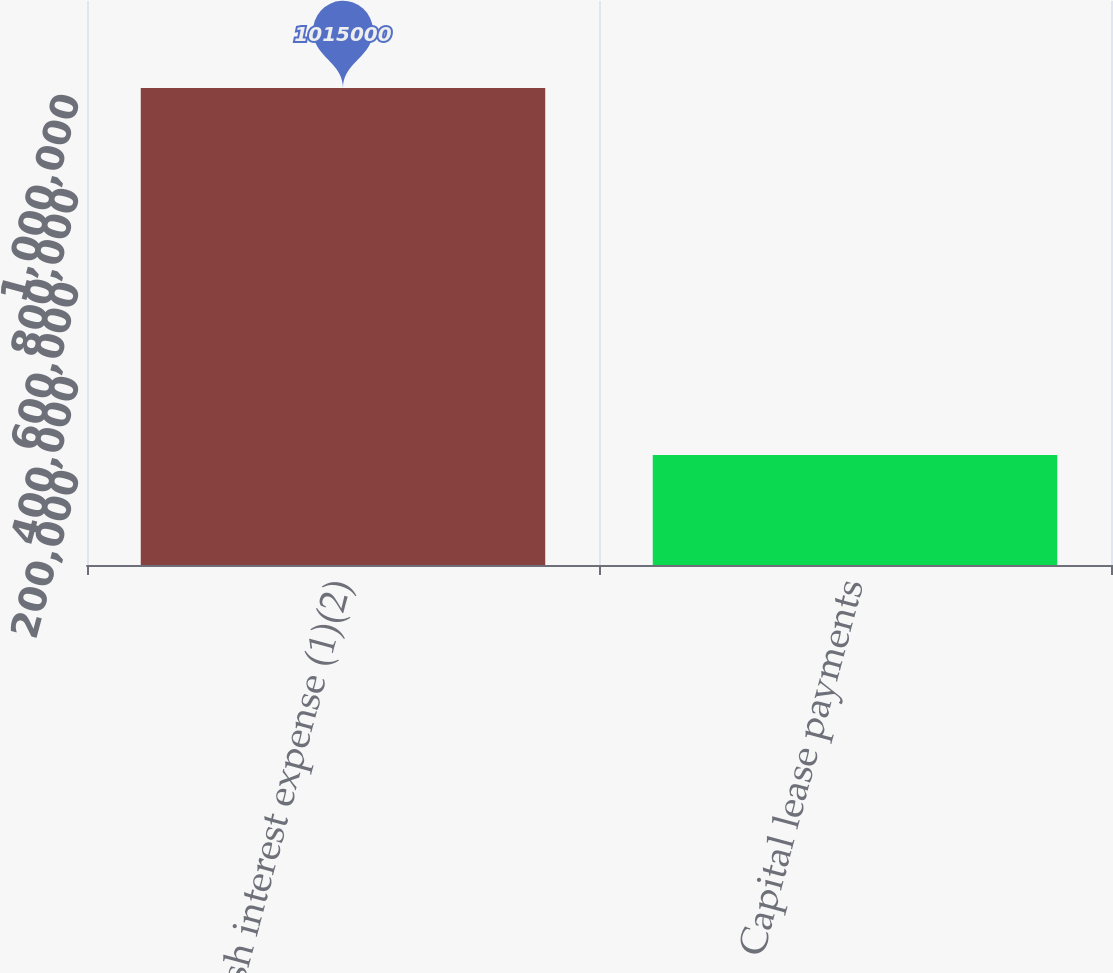<chart> <loc_0><loc_0><loc_500><loc_500><bar_chart><fcel>Cash interest expense (1)(2)<fcel>Capital lease payments<nl><fcel>1.015e+06<fcel>233899<nl></chart> 